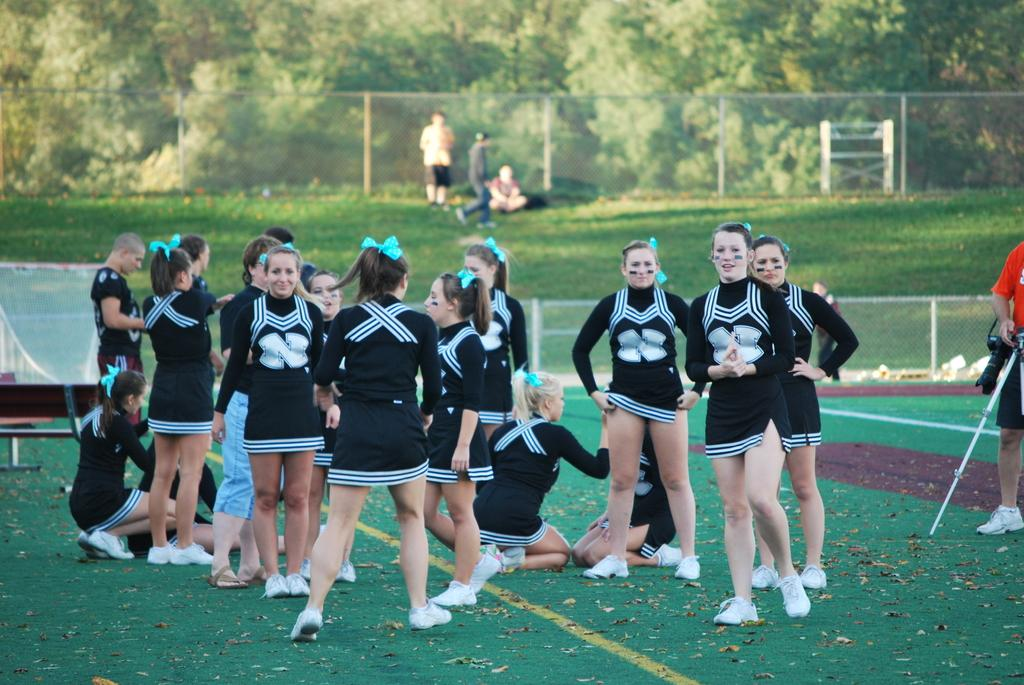What is the main subject of the image? The main subject of the image is a group of girls. What is the girls' position in the image? The girls are standing on the ground. What color are the girls' dresses? The girls are wearing black color dresses. What can be seen in the background of the image? There are green color dresses visible in the background. What type of clocks are hanging on the wall in the image? There are no clocks visible in the image; it features a group of girls wearing black dresses and green dresses in the background. What act are the girls performing in the image? The image does not depict the girls performing any specific act; they are simply standing on the ground. 